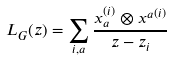Convert formula to latex. <formula><loc_0><loc_0><loc_500><loc_500>L _ { G } ( z ) = \sum _ { i , a } \frac { x _ { a } ^ { ( i ) } \otimes { x ^ { a } } ^ { ( i ) } } { z - z _ { i } }</formula> 